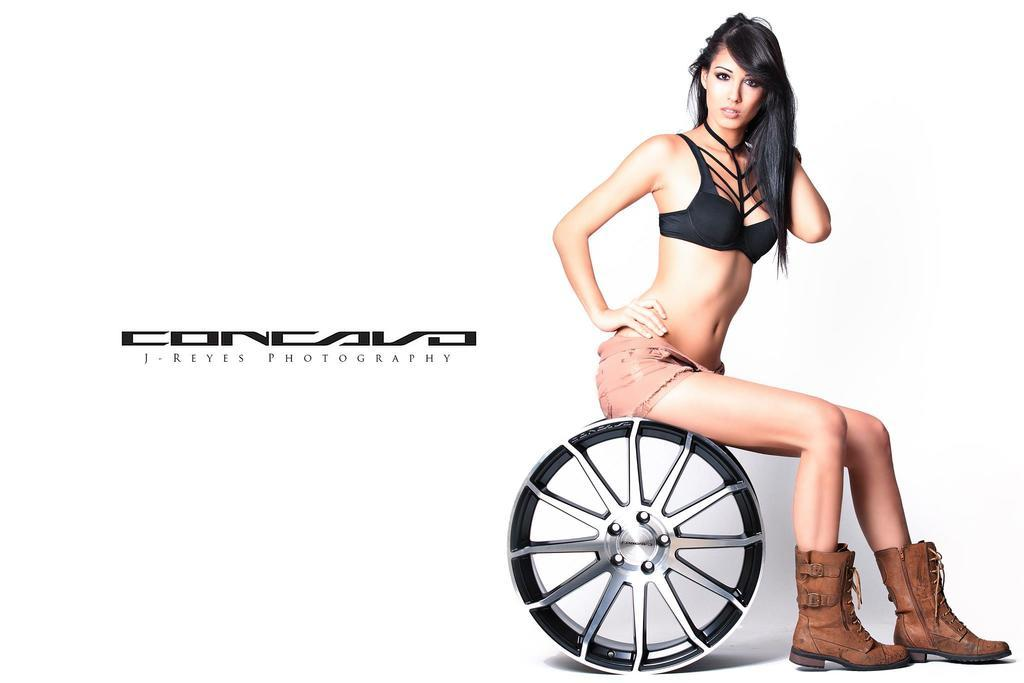What is the woman doing in the image? The woman is sitting on a wheel and giving a pose for the picture. What can be seen on the left side of the image? There is some text on the left side of the image. What is the color of the background in the image? The background of the image is white. What type of destruction can be seen in the image? There is no destruction present in the image; it features a woman sitting on a wheel and giving a pose for the picture. Can you tell me how many cars are visible in the image? There are no cars present in the image. 